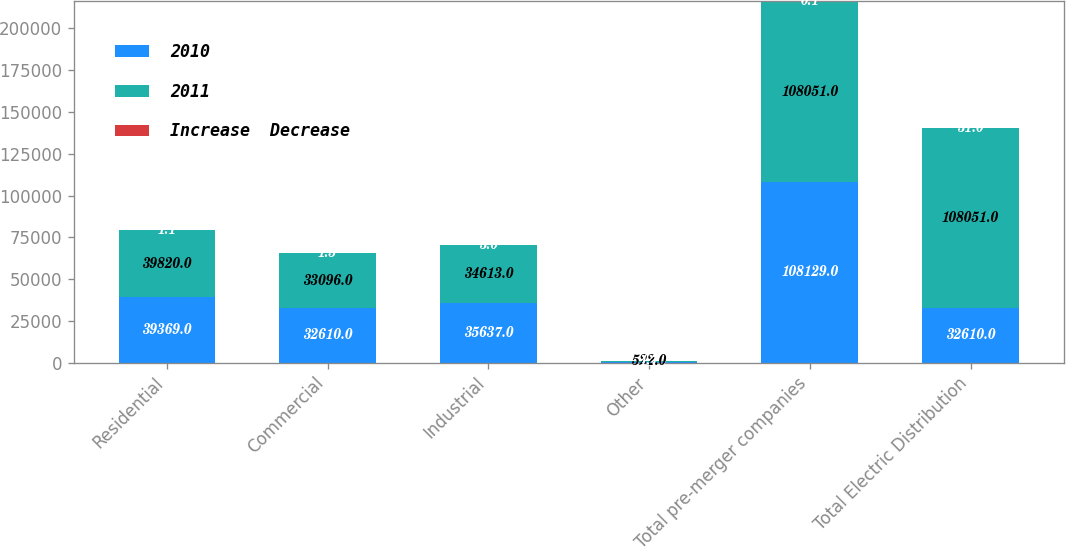Convert chart to OTSL. <chart><loc_0><loc_0><loc_500><loc_500><stacked_bar_chart><ecel><fcel>Residential<fcel>Commercial<fcel>Industrial<fcel>Other<fcel>Total pre-merger companies<fcel>Total Electric Distribution<nl><fcel>2010<fcel>39369<fcel>32610<fcel>35637<fcel>513<fcel>108129<fcel>32610<nl><fcel>2011<fcel>39820<fcel>33096<fcel>34613<fcel>522<fcel>108051<fcel>108051<nl><fcel>Increase  Decrease<fcel>1.1<fcel>1.5<fcel>3<fcel>1.7<fcel>0.1<fcel>31<nl></chart> 